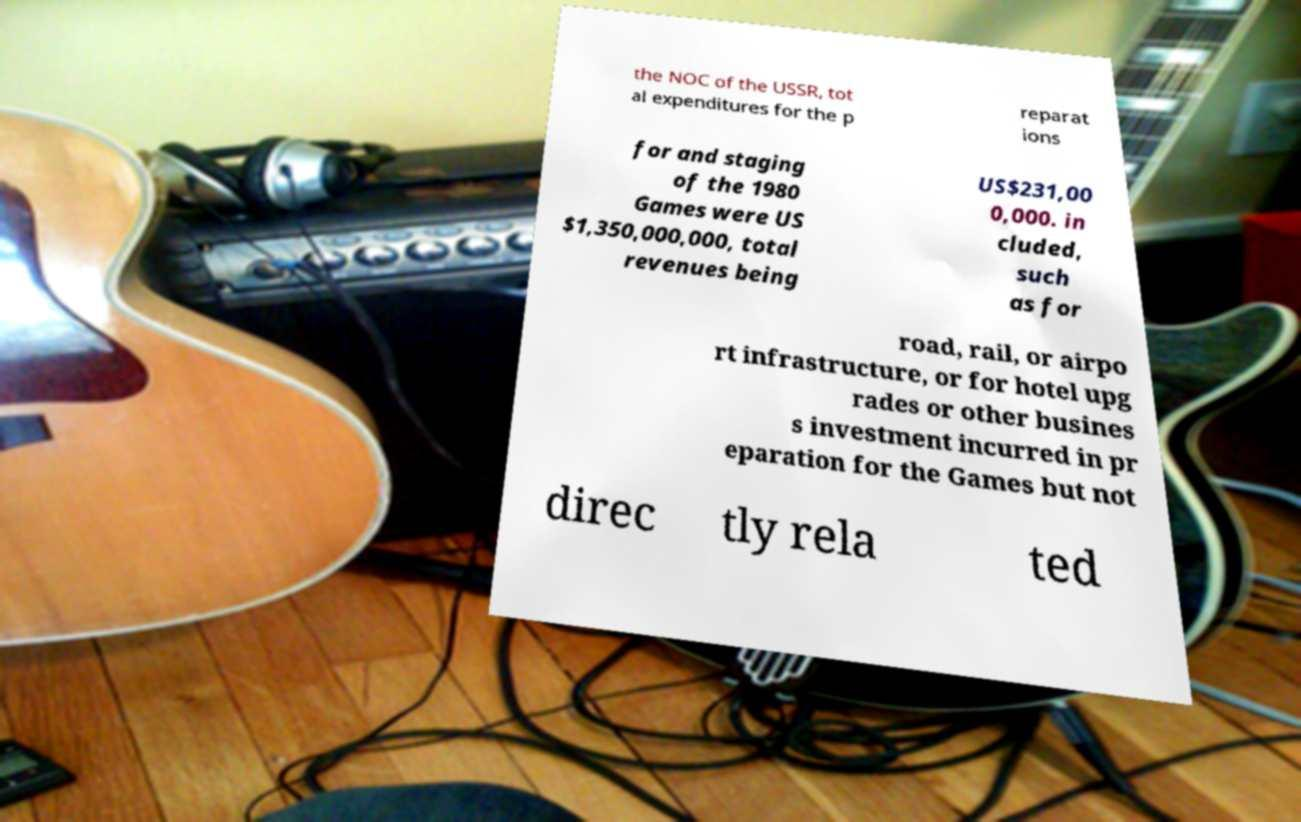For documentation purposes, I need the text within this image transcribed. Could you provide that? the NOC of the USSR, tot al expenditures for the p reparat ions for and staging of the 1980 Games were US $1,350,000,000, total revenues being US$231,00 0,000. in cluded, such as for road, rail, or airpo rt infrastructure, or for hotel upg rades or other busines s investment incurred in pr eparation for the Games but not direc tly rela ted 